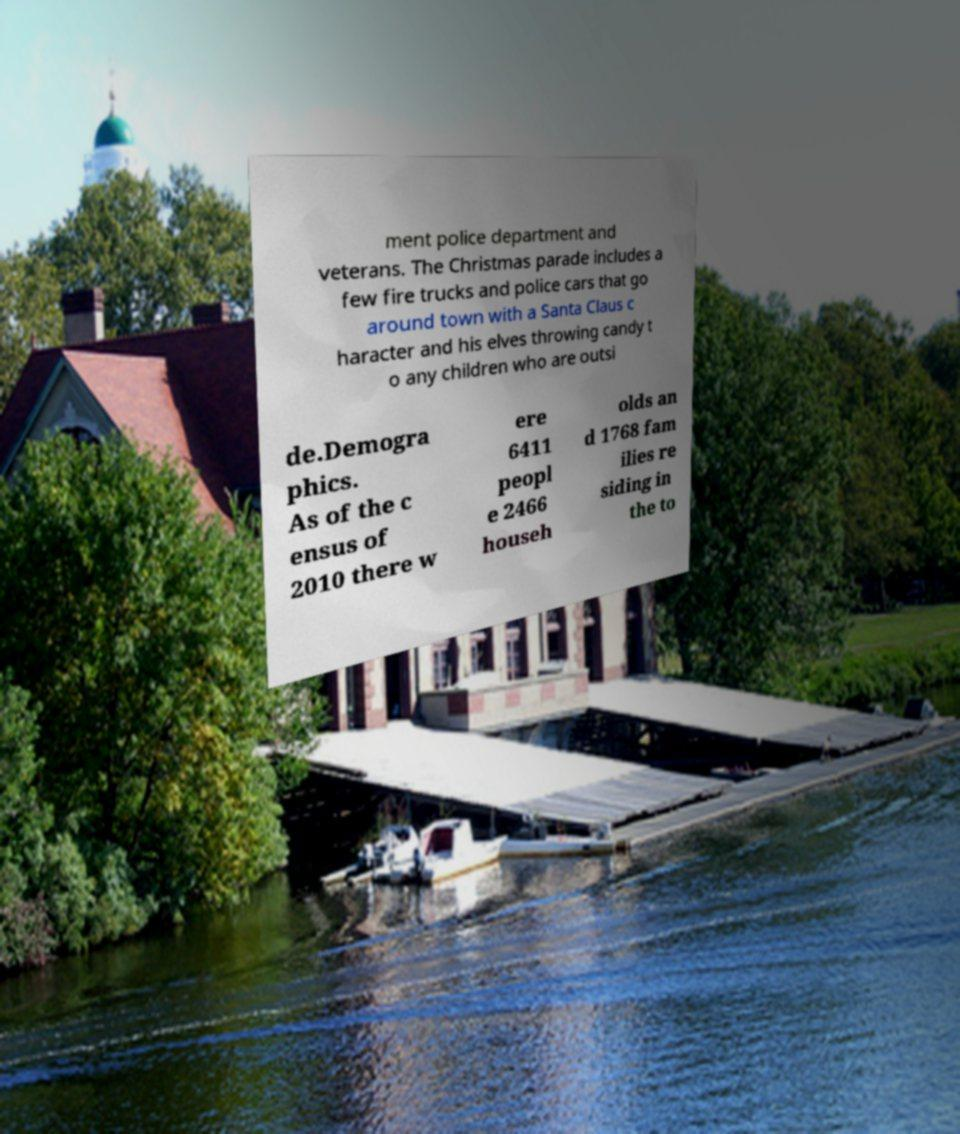Please read and relay the text visible in this image. What does it say? ment police department and veterans. The Christmas parade includes a few fire trucks and police cars that go around town with a Santa Claus c haracter and his elves throwing candy t o any children who are outsi de.Demogra phics. As of the c ensus of 2010 there w ere 6411 peopl e 2466 househ olds an d 1768 fam ilies re siding in the to 